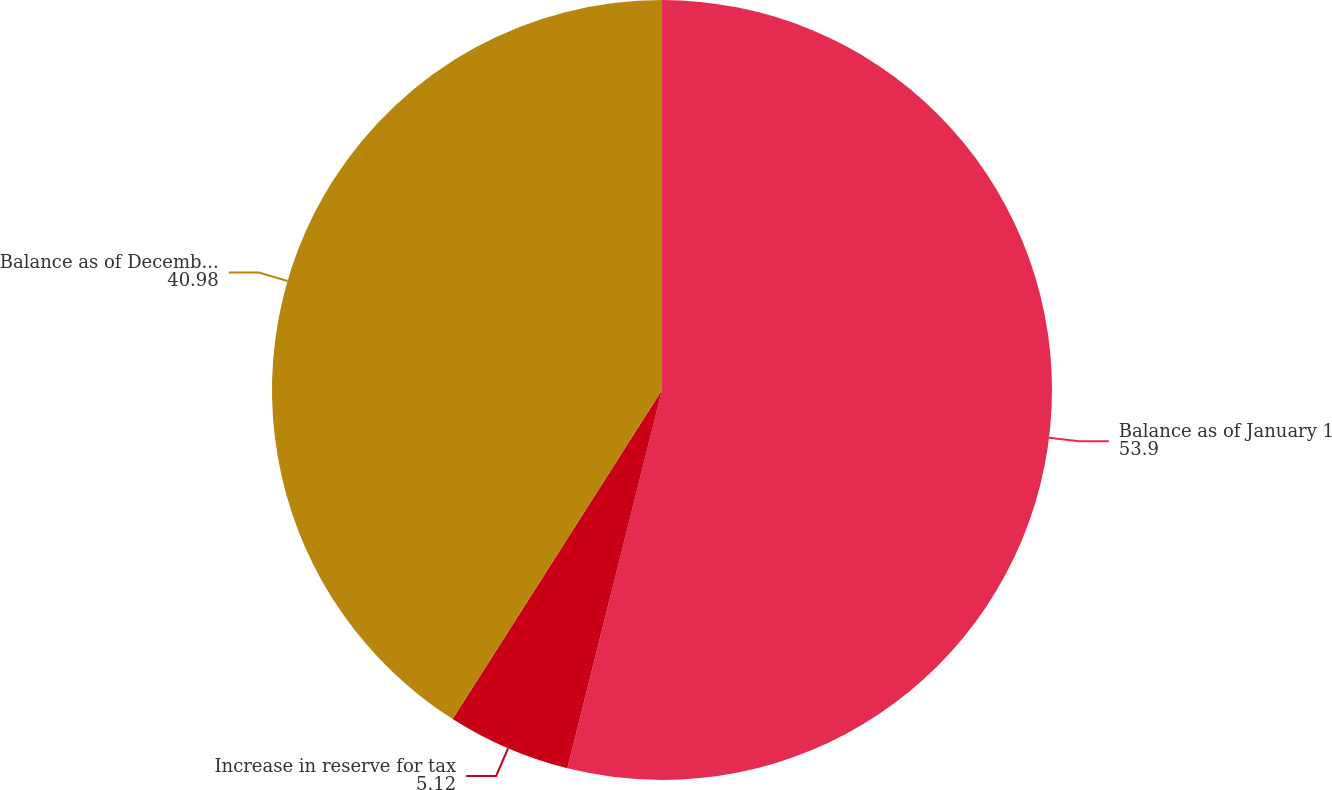<chart> <loc_0><loc_0><loc_500><loc_500><pie_chart><fcel>Balance as of January 1<fcel>Increase in reserve for tax<fcel>Balance as of December 31<nl><fcel>53.9%<fcel>5.12%<fcel>40.98%<nl></chart> 